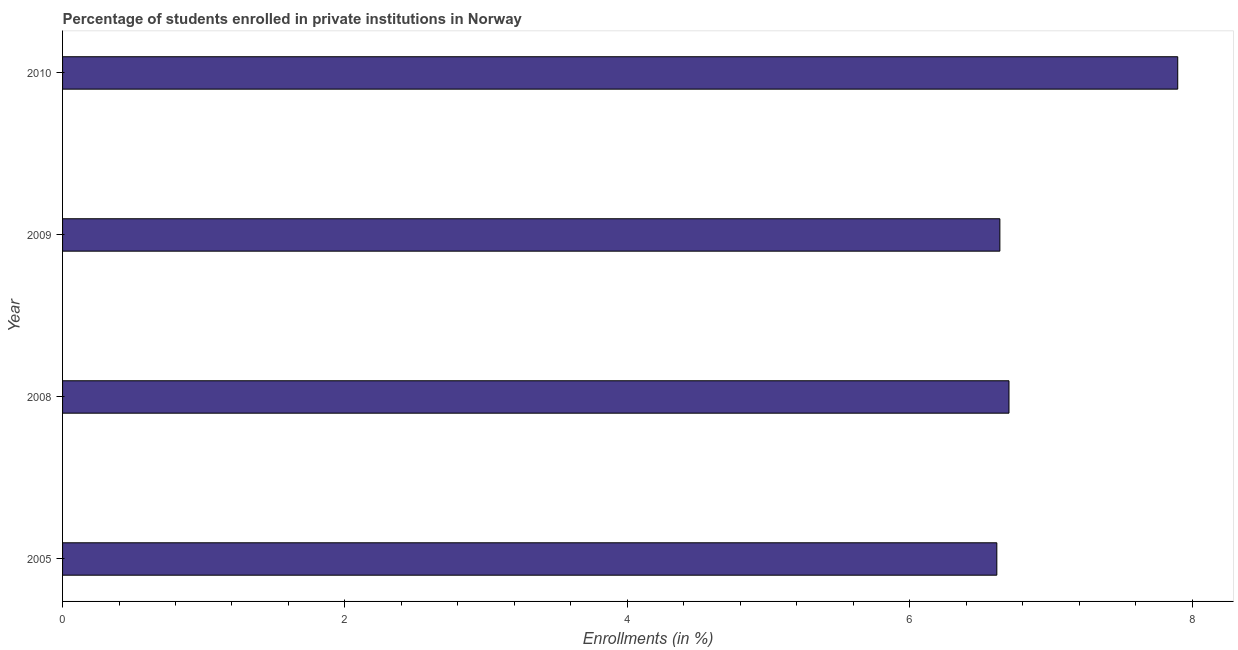Does the graph contain grids?
Your response must be concise. No. What is the title of the graph?
Give a very brief answer. Percentage of students enrolled in private institutions in Norway. What is the label or title of the X-axis?
Provide a succinct answer. Enrollments (in %). What is the enrollments in private institutions in 2009?
Your answer should be very brief. 6.64. Across all years, what is the maximum enrollments in private institutions?
Keep it short and to the point. 7.9. Across all years, what is the minimum enrollments in private institutions?
Give a very brief answer. 6.62. In which year was the enrollments in private institutions minimum?
Your answer should be very brief. 2005. What is the sum of the enrollments in private institutions?
Offer a terse response. 27.86. What is the difference between the enrollments in private institutions in 2009 and 2010?
Make the answer very short. -1.26. What is the average enrollments in private institutions per year?
Make the answer very short. 6.96. What is the median enrollments in private institutions?
Make the answer very short. 6.67. Do a majority of the years between 2008 and 2010 (inclusive) have enrollments in private institutions greater than 1.6 %?
Your answer should be compact. Yes. What is the ratio of the enrollments in private institutions in 2005 to that in 2008?
Offer a very short reply. 0.99. Is the enrollments in private institutions in 2009 less than that in 2010?
Your answer should be very brief. Yes. What is the difference between the highest and the second highest enrollments in private institutions?
Make the answer very short. 1.2. Is the sum of the enrollments in private institutions in 2008 and 2009 greater than the maximum enrollments in private institutions across all years?
Make the answer very short. Yes. What is the difference between the highest and the lowest enrollments in private institutions?
Offer a very short reply. 1.28. Are all the bars in the graph horizontal?
Keep it short and to the point. Yes. How many years are there in the graph?
Give a very brief answer. 4. Are the values on the major ticks of X-axis written in scientific E-notation?
Provide a succinct answer. No. What is the Enrollments (in %) of 2005?
Keep it short and to the point. 6.62. What is the Enrollments (in %) in 2008?
Ensure brevity in your answer.  6.7. What is the Enrollments (in %) in 2009?
Ensure brevity in your answer.  6.64. What is the Enrollments (in %) of 2010?
Keep it short and to the point. 7.9. What is the difference between the Enrollments (in %) in 2005 and 2008?
Provide a short and direct response. -0.09. What is the difference between the Enrollments (in %) in 2005 and 2009?
Provide a succinct answer. -0.02. What is the difference between the Enrollments (in %) in 2005 and 2010?
Ensure brevity in your answer.  -1.28. What is the difference between the Enrollments (in %) in 2008 and 2009?
Offer a very short reply. 0.06. What is the difference between the Enrollments (in %) in 2008 and 2010?
Offer a terse response. -1.2. What is the difference between the Enrollments (in %) in 2009 and 2010?
Provide a succinct answer. -1.26. What is the ratio of the Enrollments (in %) in 2005 to that in 2010?
Your answer should be compact. 0.84. What is the ratio of the Enrollments (in %) in 2008 to that in 2009?
Provide a succinct answer. 1.01. What is the ratio of the Enrollments (in %) in 2008 to that in 2010?
Ensure brevity in your answer.  0.85. What is the ratio of the Enrollments (in %) in 2009 to that in 2010?
Provide a short and direct response. 0.84. 